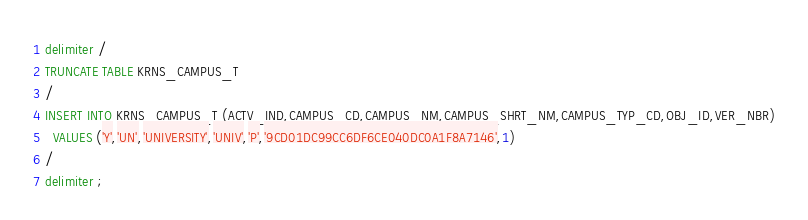Convert code to text. <code><loc_0><loc_0><loc_500><loc_500><_SQL_>delimiter /
TRUNCATE TABLE KRNS_CAMPUS_T
/
INSERT INTO KRNS_CAMPUS_T (ACTV_IND,CAMPUS_CD,CAMPUS_NM,CAMPUS_SHRT_NM,CAMPUS_TYP_CD,OBJ_ID,VER_NBR)
  VALUES ('Y','UN','UNIVERSITY','UNIV','P','9CD01DC99CC6DF6CE040DC0A1F8A7146',1)
/
delimiter ;
</code> 